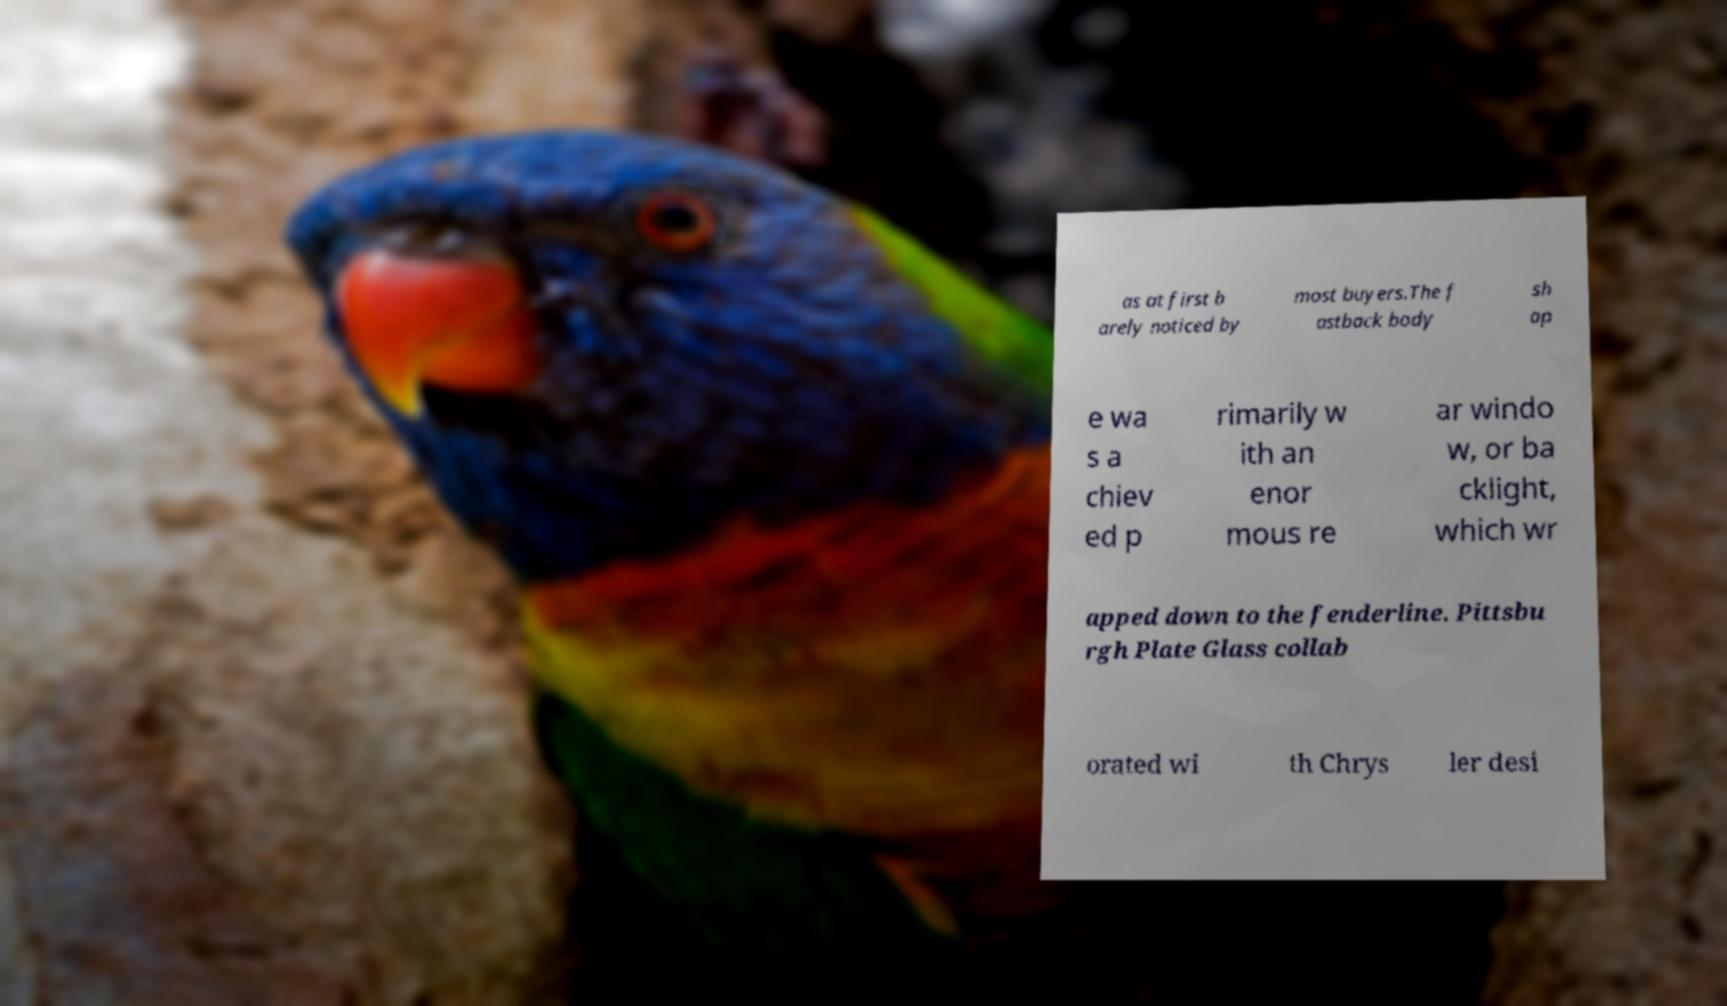There's text embedded in this image that I need extracted. Can you transcribe it verbatim? as at first b arely noticed by most buyers.The f astback body sh ap e wa s a chiev ed p rimarily w ith an enor mous re ar windo w, or ba cklight, which wr apped down to the fenderline. Pittsbu rgh Plate Glass collab orated wi th Chrys ler desi 